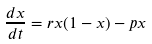<formula> <loc_0><loc_0><loc_500><loc_500>\frac { d x } { d t } = r x ( 1 - x ) - p x</formula> 